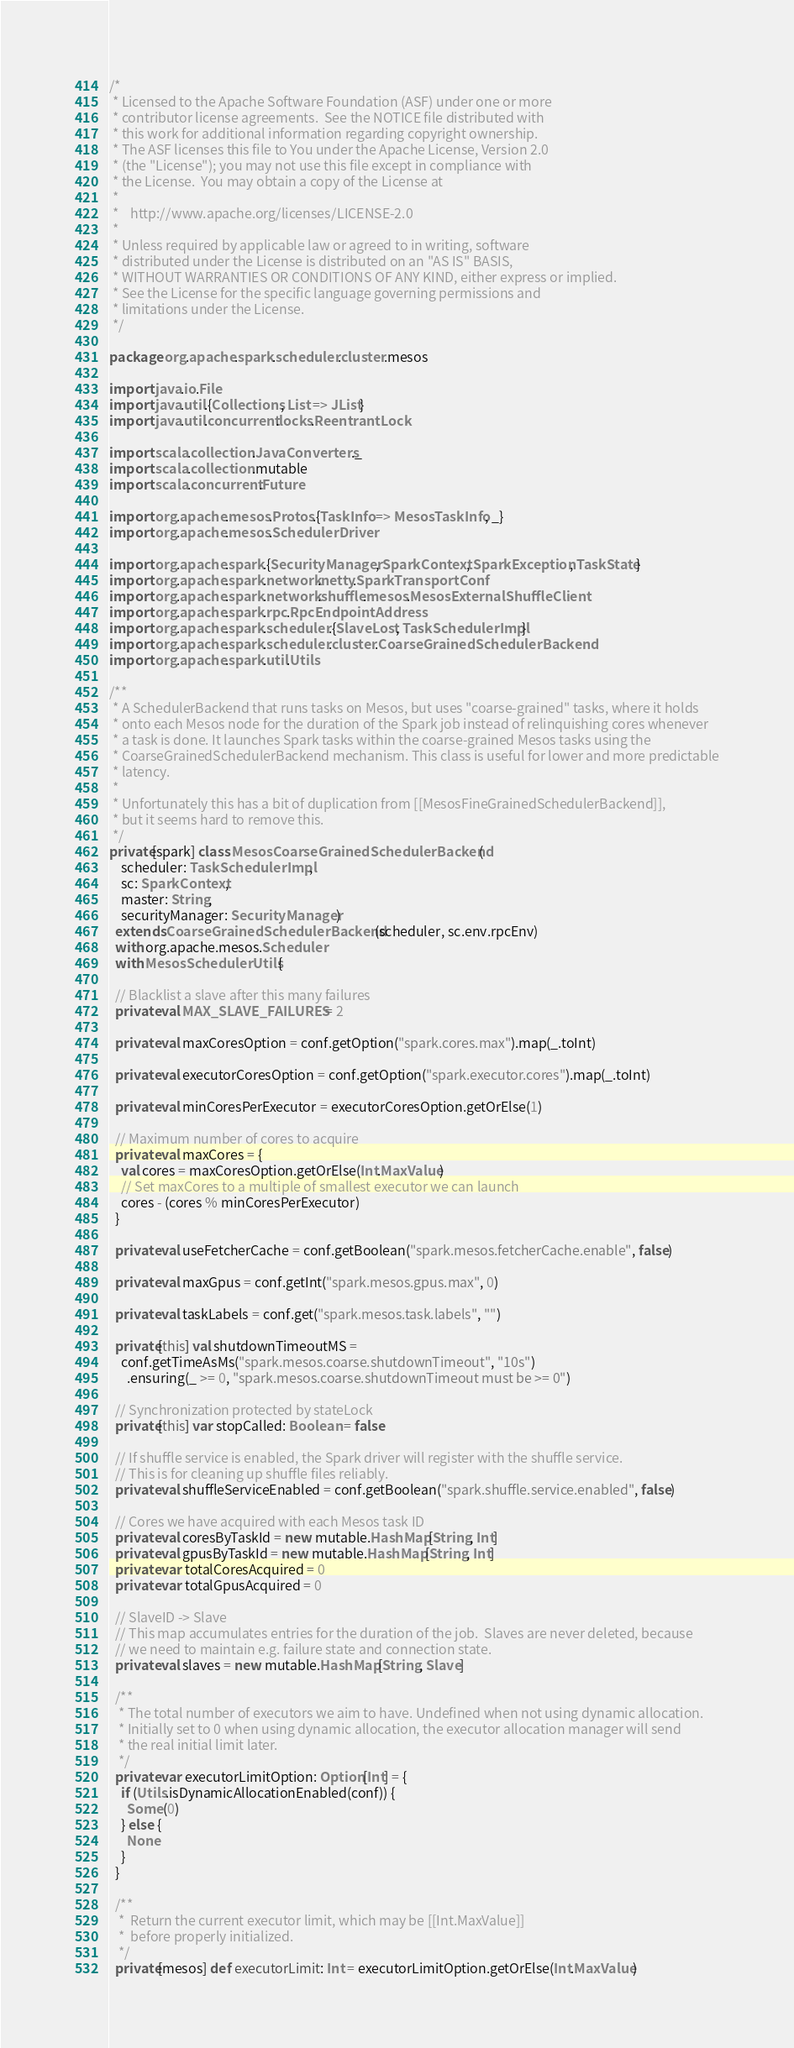<code> <loc_0><loc_0><loc_500><loc_500><_Scala_>/*
 * Licensed to the Apache Software Foundation (ASF) under one or more
 * contributor license agreements.  See the NOTICE file distributed with
 * this work for additional information regarding copyright ownership.
 * The ASF licenses this file to You under the Apache License, Version 2.0
 * (the "License"); you may not use this file except in compliance with
 * the License.  You may obtain a copy of the License at
 *
 *    http://www.apache.org/licenses/LICENSE-2.0
 *
 * Unless required by applicable law or agreed to in writing, software
 * distributed under the License is distributed on an "AS IS" BASIS,
 * WITHOUT WARRANTIES OR CONDITIONS OF ANY KIND, either express or implied.
 * See the License for the specific language governing permissions and
 * limitations under the License.
 */

package org.apache.spark.scheduler.cluster.mesos

import java.io.File
import java.util.{Collections, List => JList}
import java.util.concurrent.locks.ReentrantLock

import scala.collection.JavaConverters._
import scala.collection.mutable
import scala.concurrent.Future

import org.apache.mesos.Protos.{TaskInfo => MesosTaskInfo, _}
import org.apache.mesos.SchedulerDriver

import org.apache.spark.{SecurityManager, SparkContext, SparkException, TaskState}
import org.apache.spark.network.netty.SparkTransportConf
import org.apache.spark.network.shuffle.mesos.MesosExternalShuffleClient
import org.apache.spark.rpc.RpcEndpointAddress
import org.apache.spark.scheduler.{SlaveLost, TaskSchedulerImpl}
import org.apache.spark.scheduler.cluster.CoarseGrainedSchedulerBackend
import org.apache.spark.util.Utils

/**
 * A SchedulerBackend that runs tasks on Mesos, but uses "coarse-grained" tasks, where it holds
 * onto each Mesos node for the duration of the Spark job instead of relinquishing cores whenever
 * a task is done. It launches Spark tasks within the coarse-grained Mesos tasks using the
 * CoarseGrainedSchedulerBackend mechanism. This class is useful for lower and more predictable
 * latency.
 *
 * Unfortunately this has a bit of duplication from [[MesosFineGrainedSchedulerBackend]],
 * but it seems hard to remove this.
 */
private[spark] class MesosCoarseGrainedSchedulerBackend(
    scheduler: TaskSchedulerImpl,
    sc: SparkContext,
    master: String,
    securityManager: SecurityManager)
  extends CoarseGrainedSchedulerBackend(scheduler, sc.env.rpcEnv)
  with org.apache.mesos.Scheduler
  with MesosSchedulerUtils {

  // Blacklist a slave after this many failures
  private val MAX_SLAVE_FAILURES = 2

  private val maxCoresOption = conf.getOption("spark.cores.max").map(_.toInt)

  private val executorCoresOption = conf.getOption("spark.executor.cores").map(_.toInt)

  private val minCoresPerExecutor = executorCoresOption.getOrElse(1)

  // Maximum number of cores to acquire
  private val maxCores = {
    val cores = maxCoresOption.getOrElse(Int.MaxValue)
    // Set maxCores to a multiple of smallest executor we can launch
    cores - (cores % minCoresPerExecutor)
  }

  private val useFetcherCache = conf.getBoolean("spark.mesos.fetcherCache.enable", false)

  private val maxGpus = conf.getInt("spark.mesos.gpus.max", 0)

  private val taskLabels = conf.get("spark.mesos.task.labels", "")

  private[this] val shutdownTimeoutMS =
    conf.getTimeAsMs("spark.mesos.coarse.shutdownTimeout", "10s")
      .ensuring(_ >= 0, "spark.mesos.coarse.shutdownTimeout must be >= 0")

  // Synchronization protected by stateLock
  private[this] var stopCalled: Boolean = false

  // If shuffle service is enabled, the Spark driver will register with the shuffle service.
  // This is for cleaning up shuffle files reliably.
  private val shuffleServiceEnabled = conf.getBoolean("spark.shuffle.service.enabled", false)

  // Cores we have acquired with each Mesos task ID
  private val coresByTaskId = new mutable.HashMap[String, Int]
  private val gpusByTaskId = new mutable.HashMap[String, Int]
  private var totalCoresAcquired = 0
  private var totalGpusAcquired = 0

  // SlaveID -> Slave
  // This map accumulates entries for the duration of the job.  Slaves are never deleted, because
  // we need to maintain e.g. failure state and connection state.
  private val slaves = new mutable.HashMap[String, Slave]

  /**
   * The total number of executors we aim to have. Undefined when not using dynamic allocation.
   * Initially set to 0 when using dynamic allocation, the executor allocation manager will send
   * the real initial limit later.
   */
  private var executorLimitOption: Option[Int] = {
    if (Utils.isDynamicAllocationEnabled(conf)) {
      Some(0)
    } else {
      None
    }
  }

  /**
   *  Return the current executor limit, which may be [[Int.MaxValue]]
   *  before properly initialized.
   */
  private[mesos] def executorLimit: Int = executorLimitOption.getOrElse(Int.MaxValue)
</code> 